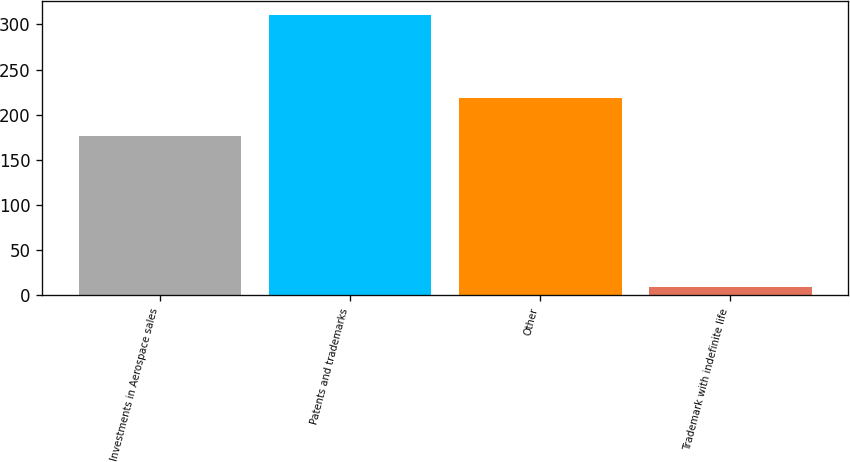<chart> <loc_0><loc_0><loc_500><loc_500><bar_chart><fcel>Investments in Aerospace sales<fcel>Patents and trademarks<fcel>Other<fcel>Trademark with indefinite life<nl><fcel>176<fcel>310<fcel>219<fcel>9<nl></chart> 